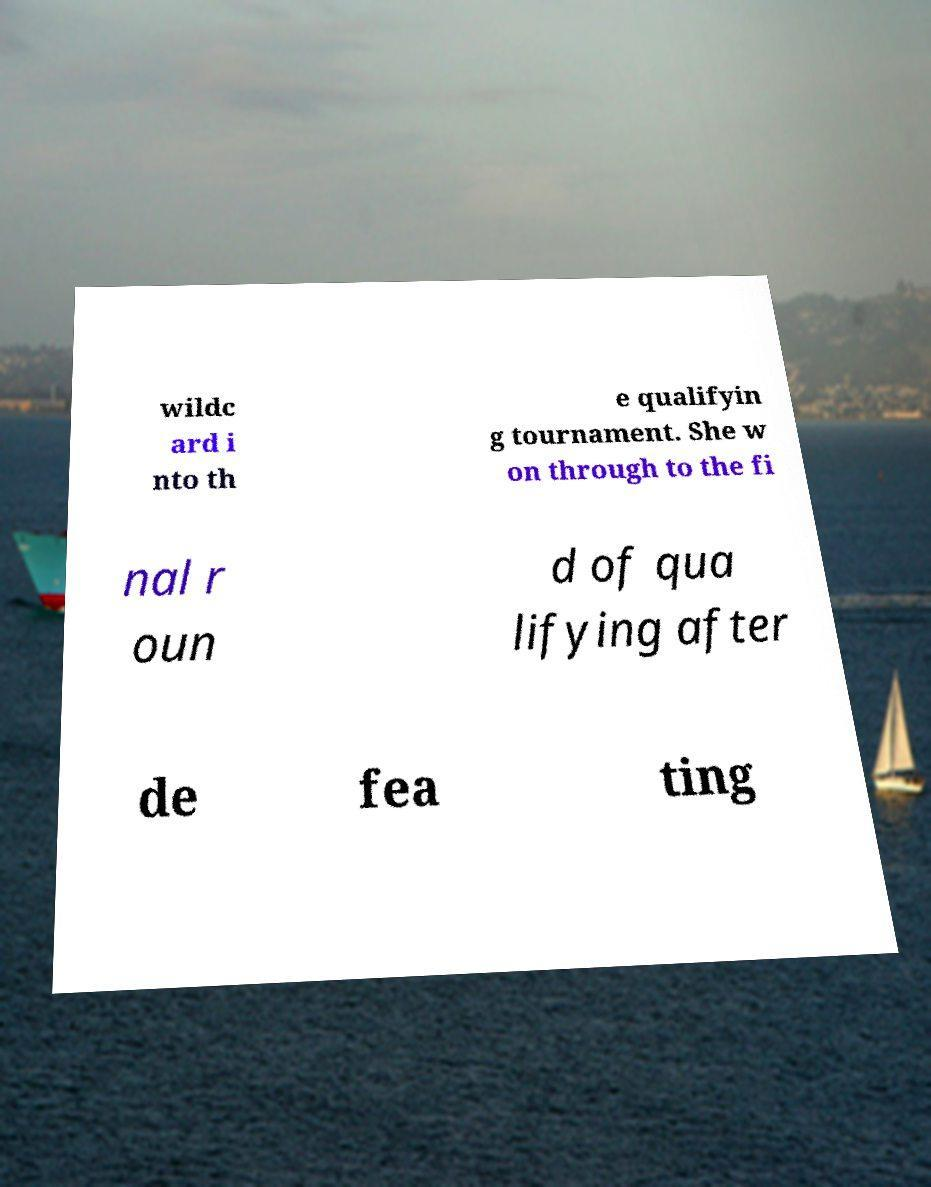I need the written content from this picture converted into text. Can you do that? wildc ard i nto th e qualifyin g tournament. She w on through to the fi nal r oun d of qua lifying after de fea ting 